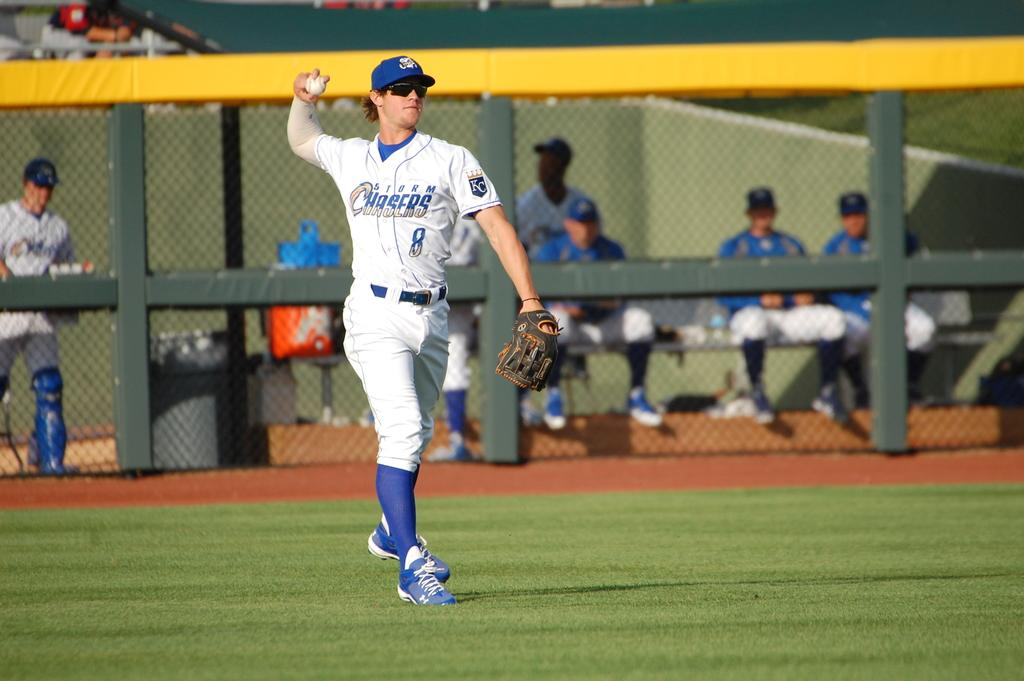<image>
Share a concise interpretation of the image provided. single man playing baseball on the field number 8 